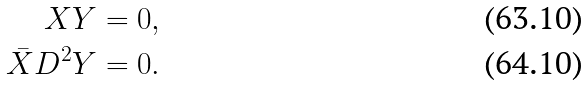<formula> <loc_0><loc_0><loc_500><loc_500>X Y & = 0 , \\ \bar { X } D ^ { 2 } Y & = 0 .</formula> 